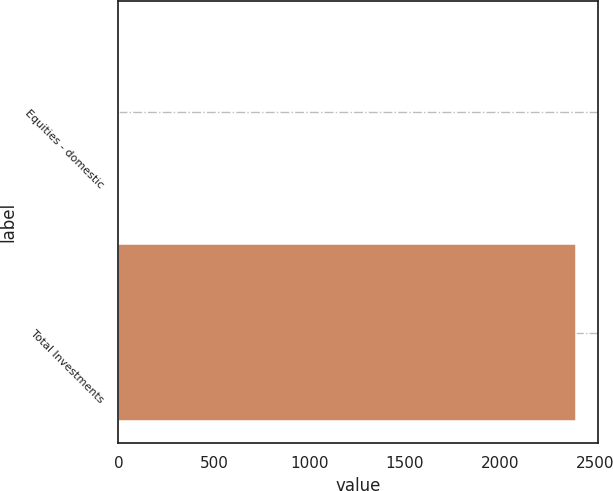Convert chart. <chart><loc_0><loc_0><loc_500><loc_500><bar_chart><fcel>Equities - domestic<fcel>Total Investments<nl><fcel>3<fcel>2397<nl></chart> 